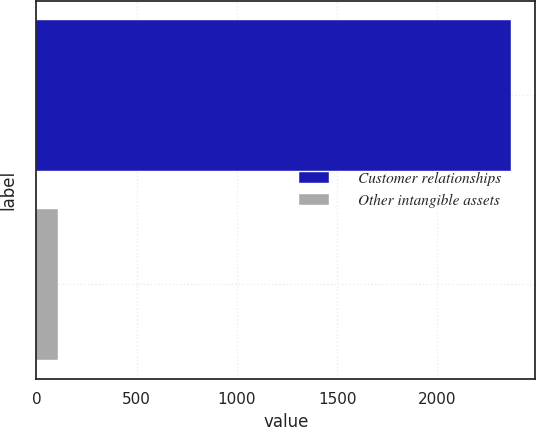<chart> <loc_0><loc_0><loc_500><loc_500><bar_chart><fcel>Customer relationships<fcel>Other intangible assets<nl><fcel>2368<fcel>105<nl></chart> 